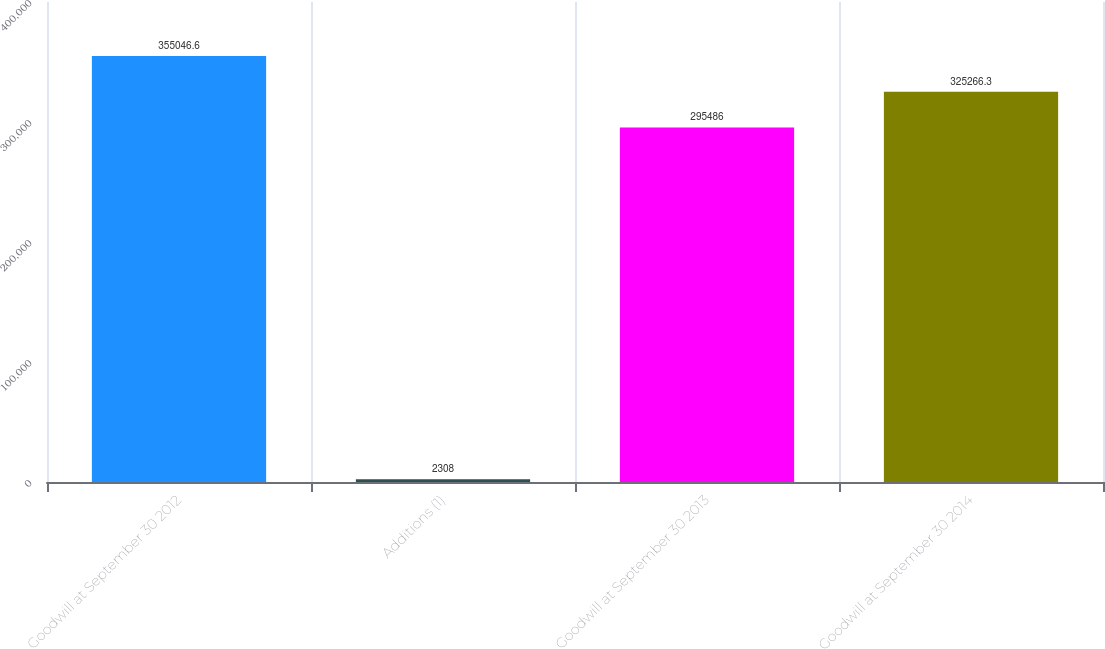Convert chart to OTSL. <chart><loc_0><loc_0><loc_500><loc_500><bar_chart><fcel>Goodwill at September 30 2012<fcel>Additions (1)<fcel>Goodwill at September 30 2013<fcel>Goodwill at September 30 2014<nl><fcel>355047<fcel>2308<fcel>295486<fcel>325266<nl></chart> 